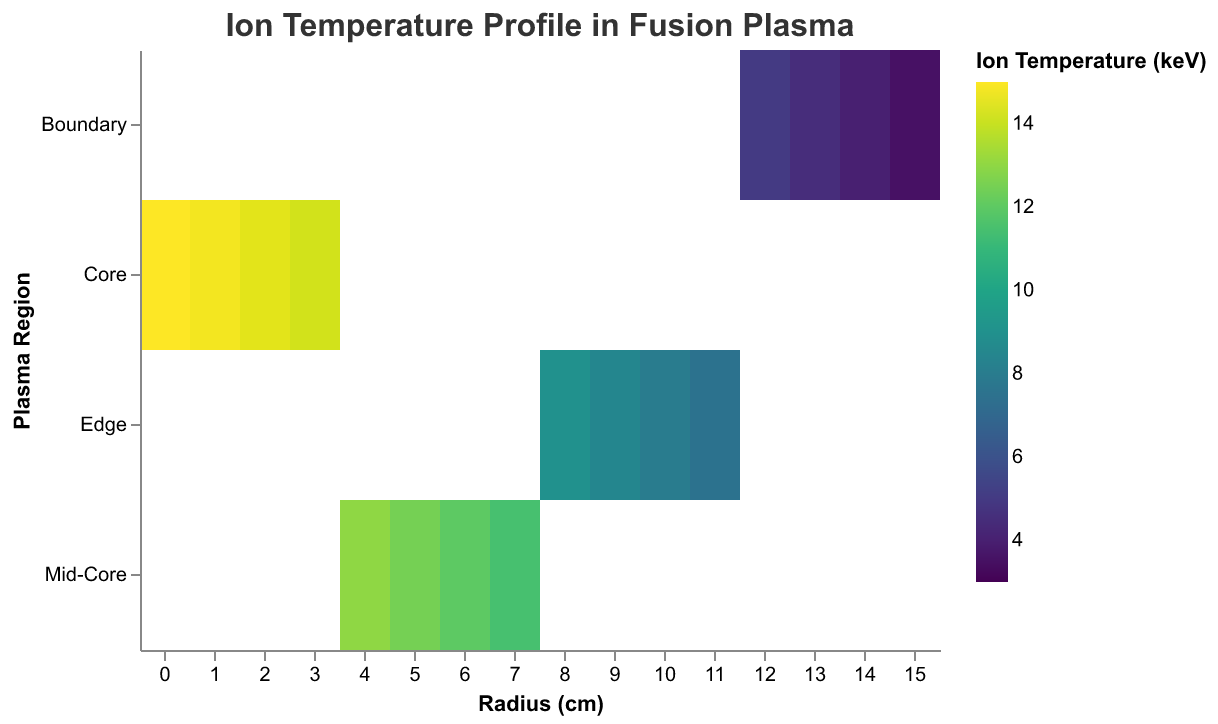What is the title of the heatmap? The title is displayed at the top of the heatmap in the center. It indicates what the figure is about.
Answer: Ion Temperature Profile in Fusion Plasma What is the Ion Temperature in the Core region at Radius 2 cm? Locate the "Core" region on the y-axis and then move to the 2 cm mark on the x-axis. The color at this intersecting point corresponds to the Ion Temperature. Here, it is indicated by the legend on the right.
Answer: 14.5 keV Which plasma region has the highest Ion Temperature? The highest temperature corresponds to the darkest color in the "viridis" color scheme used. By looking at the color gradients, the "Core" region at the smallest radius (near 0 cm) has the darkest color.
Answer: Core What is the difference in Ion Temperature between the Core at 0 cm and the Mid-Core at 6 cm? Find the Ion Temperature for the Core region at 0 cm (15 keV) and for the Mid-Core at 6 cm (12 keV). Subtract the latter from the former: 15 - 12 = 3.
Answer: 3 keV Which region shows the steepest decline in Ion Temperature as the radius increases? Observe the rate of color change along the horizontal axis for different regions. The boundary region shows a rapid change in color, indicating a steep decline in Ion Temperature.
Answer: Boundary What is the average Ion Temperature in the Edge region? Sum the Ion Temperatures in the Edge region at radii 8, 9, 10, and 11 cm (9, 8.5, 8, 7.5 keV respectively) and divide by the number of data points, i.e., (9 + 8.5 + 8 + 7.5)/4. The result is (33) / 4 = 8.25.
Answer: 8.25 keV How does the Ion Temperature change from Radius 0 cm to Radius 15 cm across all regions? Starting from the Core (highest temperature) and moving through Mid-Core, Edge, and Boundary (lowest temperature), the Ion Temperature generally decreases. This is observed by the color transition from dark to light as the radius increases.
Answer: Decreases In which region(s) does the Ion Temperature fall below 10 keV? Identify points in the heatmap where the Ion Temperature is lighter in color corresponding to values below 10 keV. This occurs from the Edge region (Radius 8 cm onwards) and through the Boundary region.
Answer: Edge and Boundary What is the color scheme used in the heatmap and what does it represent? The color scheme "viridis" is used, where colors represent different Ion Temperatures on a gradient. Darker colors indicate higher temperatures while lighter colors indicate lower temperatures.
Answer: Viridis, temperature gradient 